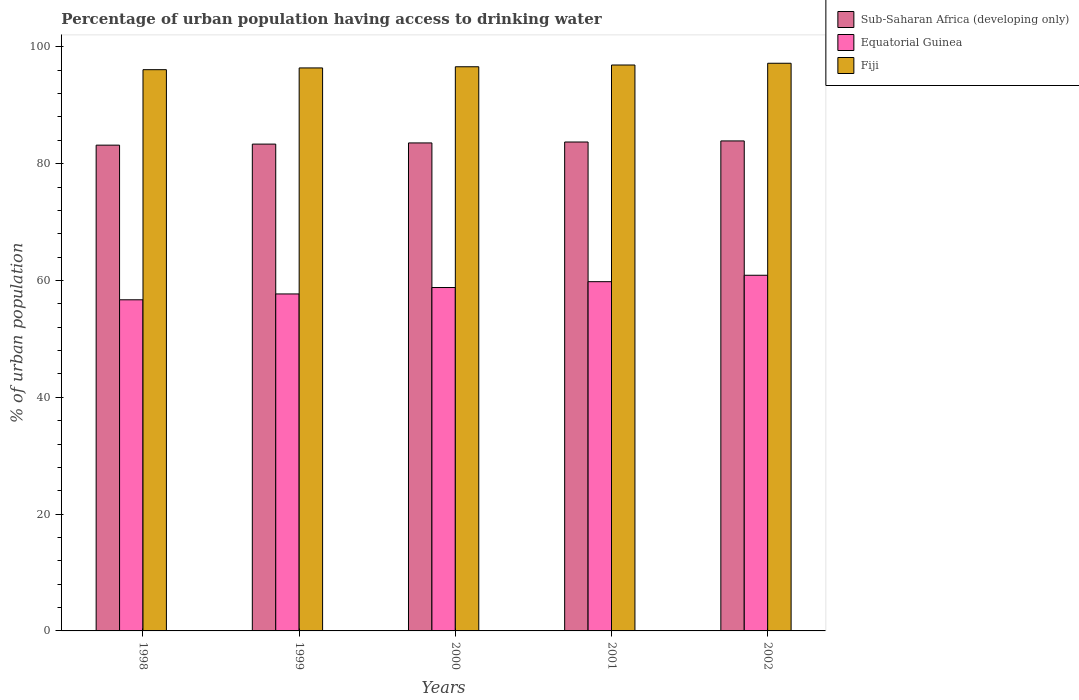How many different coloured bars are there?
Offer a very short reply. 3. How many groups of bars are there?
Provide a short and direct response. 5. Are the number of bars per tick equal to the number of legend labels?
Your response must be concise. Yes. In how many cases, is the number of bars for a given year not equal to the number of legend labels?
Offer a very short reply. 0. What is the percentage of urban population having access to drinking water in Equatorial Guinea in 2002?
Provide a succinct answer. 60.9. Across all years, what is the maximum percentage of urban population having access to drinking water in Sub-Saharan Africa (developing only)?
Your response must be concise. 83.9. Across all years, what is the minimum percentage of urban population having access to drinking water in Sub-Saharan Africa (developing only)?
Make the answer very short. 83.18. In which year was the percentage of urban population having access to drinking water in Equatorial Guinea maximum?
Make the answer very short. 2002. What is the total percentage of urban population having access to drinking water in Sub-Saharan Africa (developing only) in the graph?
Give a very brief answer. 417.71. What is the difference between the percentage of urban population having access to drinking water in Fiji in 2000 and that in 2001?
Ensure brevity in your answer.  -0.3. What is the difference between the percentage of urban population having access to drinking water in Fiji in 2001 and the percentage of urban population having access to drinking water in Sub-Saharan Africa (developing only) in 2002?
Provide a succinct answer. 13. What is the average percentage of urban population having access to drinking water in Sub-Saharan Africa (developing only) per year?
Give a very brief answer. 83.54. In the year 2001, what is the difference between the percentage of urban population having access to drinking water in Fiji and percentage of urban population having access to drinking water in Sub-Saharan Africa (developing only)?
Your answer should be compact. 13.18. What is the ratio of the percentage of urban population having access to drinking water in Sub-Saharan Africa (developing only) in 2000 to that in 2001?
Offer a very short reply. 1. What is the difference between the highest and the second highest percentage of urban population having access to drinking water in Sub-Saharan Africa (developing only)?
Give a very brief answer. 0.18. What is the difference between the highest and the lowest percentage of urban population having access to drinking water in Fiji?
Give a very brief answer. 1.1. In how many years, is the percentage of urban population having access to drinking water in Sub-Saharan Africa (developing only) greater than the average percentage of urban population having access to drinking water in Sub-Saharan Africa (developing only) taken over all years?
Your response must be concise. 3. What does the 1st bar from the left in 1999 represents?
Offer a very short reply. Sub-Saharan Africa (developing only). What does the 2nd bar from the right in 2001 represents?
Keep it short and to the point. Equatorial Guinea. Is it the case that in every year, the sum of the percentage of urban population having access to drinking water in Sub-Saharan Africa (developing only) and percentage of urban population having access to drinking water in Equatorial Guinea is greater than the percentage of urban population having access to drinking water in Fiji?
Give a very brief answer. Yes. How many bars are there?
Offer a terse response. 15. Are all the bars in the graph horizontal?
Keep it short and to the point. No. What is the difference between two consecutive major ticks on the Y-axis?
Your answer should be compact. 20. Are the values on the major ticks of Y-axis written in scientific E-notation?
Make the answer very short. No. Does the graph contain grids?
Offer a very short reply. No. What is the title of the graph?
Make the answer very short. Percentage of urban population having access to drinking water. Does "San Marino" appear as one of the legend labels in the graph?
Your response must be concise. No. What is the label or title of the X-axis?
Your answer should be very brief. Years. What is the label or title of the Y-axis?
Offer a terse response. % of urban population. What is the % of urban population of Sub-Saharan Africa (developing only) in 1998?
Offer a terse response. 83.18. What is the % of urban population of Equatorial Guinea in 1998?
Give a very brief answer. 56.7. What is the % of urban population in Fiji in 1998?
Your response must be concise. 96.1. What is the % of urban population in Sub-Saharan Africa (developing only) in 1999?
Ensure brevity in your answer.  83.36. What is the % of urban population in Equatorial Guinea in 1999?
Keep it short and to the point. 57.7. What is the % of urban population of Fiji in 1999?
Your response must be concise. 96.4. What is the % of urban population of Sub-Saharan Africa (developing only) in 2000?
Offer a very short reply. 83.56. What is the % of urban population in Equatorial Guinea in 2000?
Your response must be concise. 58.8. What is the % of urban population in Fiji in 2000?
Offer a terse response. 96.6. What is the % of urban population in Sub-Saharan Africa (developing only) in 2001?
Make the answer very short. 83.72. What is the % of urban population of Equatorial Guinea in 2001?
Your response must be concise. 59.8. What is the % of urban population in Fiji in 2001?
Your answer should be compact. 96.9. What is the % of urban population of Sub-Saharan Africa (developing only) in 2002?
Offer a very short reply. 83.9. What is the % of urban population in Equatorial Guinea in 2002?
Provide a succinct answer. 60.9. What is the % of urban population of Fiji in 2002?
Make the answer very short. 97.2. Across all years, what is the maximum % of urban population of Sub-Saharan Africa (developing only)?
Offer a terse response. 83.9. Across all years, what is the maximum % of urban population in Equatorial Guinea?
Keep it short and to the point. 60.9. Across all years, what is the maximum % of urban population of Fiji?
Provide a succinct answer. 97.2. Across all years, what is the minimum % of urban population of Sub-Saharan Africa (developing only)?
Your answer should be compact. 83.18. Across all years, what is the minimum % of urban population of Equatorial Guinea?
Keep it short and to the point. 56.7. Across all years, what is the minimum % of urban population in Fiji?
Provide a succinct answer. 96.1. What is the total % of urban population of Sub-Saharan Africa (developing only) in the graph?
Offer a very short reply. 417.71. What is the total % of urban population of Equatorial Guinea in the graph?
Provide a succinct answer. 293.9. What is the total % of urban population of Fiji in the graph?
Your answer should be very brief. 483.2. What is the difference between the % of urban population in Sub-Saharan Africa (developing only) in 1998 and that in 1999?
Provide a succinct answer. -0.18. What is the difference between the % of urban population of Fiji in 1998 and that in 1999?
Provide a succinct answer. -0.3. What is the difference between the % of urban population of Sub-Saharan Africa (developing only) in 1998 and that in 2000?
Offer a terse response. -0.38. What is the difference between the % of urban population of Equatorial Guinea in 1998 and that in 2000?
Keep it short and to the point. -2.1. What is the difference between the % of urban population in Fiji in 1998 and that in 2000?
Offer a very short reply. -0.5. What is the difference between the % of urban population of Sub-Saharan Africa (developing only) in 1998 and that in 2001?
Make the answer very short. -0.54. What is the difference between the % of urban population of Fiji in 1998 and that in 2001?
Offer a terse response. -0.8. What is the difference between the % of urban population in Sub-Saharan Africa (developing only) in 1998 and that in 2002?
Ensure brevity in your answer.  -0.72. What is the difference between the % of urban population of Equatorial Guinea in 1998 and that in 2002?
Provide a short and direct response. -4.2. What is the difference between the % of urban population of Fiji in 1998 and that in 2002?
Your response must be concise. -1.1. What is the difference between the % of urban population of Sub-Saharan Africa (developing only) in 1999 and that in 2000?
Ensure brevity in your answer.  -0.2. What is the difference between the % of urban population of Fiji in 1999 and that in 2000?
Offer a terse response. -0.2. What is the difference between the % of urban population of Sub-Saharan Africa (developing only) in 1999 and that in 2001?
Provide a succinct answer. -0.36. What is the difference between the % of urban population in Equatorial Guinea in 1999 and that in 2001?
Ensure brevity in your answer.  -2.1. What is the difference between the % of urban population of Fiji in 1999 and that in 2001?
Ensure brevity in your answer.  -0.5. What is the difference between the % of urban population in Sub-Saharan Africa (developing only) in 1999 and that in 2002?
Offer a terse response. -0.54. What is the difference between the % of urban population in Fiji in 1999 and that in 2002?
Provide a short and direct response. -0.8. What is the difference between the % of urban population in Sub-Saharan Africa (developing only) in 2000 and that in 2001?
Ensure brevity in your answer.  -0.16. What is the difference between the % of urban population of Equatorial Guinea in 2000 and that in 2001?
Keep it short and to the point. -1. What is the difference between the % of urban population of Sub-Saharan Africa (developing only) in 2000 and that in 2002?
Your response must be concise. -0.34. What is the difference between the % of urban population in Sub-Saharan Africa (developing only) in 2001 and that in 2002?
Offer a terse response. -0.18. What is the difference between the % of urban population of Equatorial Guinea in 2001 and that in 2002?
Offer a terse response. -1.1. What is the difference between the % of urban population of Sub-Saharan Africa (developing only) in 1998 and the % of urban population of Equatorial Guinea in 1999?
Offer a very short reply. 25.48. What is the difference between the % of urban population in Sub-Saharan Africa (developing only) in 1998 and the % of urban population in Fiji in 1999?
Provide a short and direct response. -13.22. What is the difference between the % of urban population in Equatorial Guinea in 1998 and the % of urban population in Fiji in 1999?
Your answer should be very brief. -39.7. What is the difference between the % of urban population in Sub-Saharan Africa (developing only) in 1998 and the % of urban population in Equatorial Guinea in 2000?
Your response must be concise. 24.38. What is the difference between the % of urban population in Sub-Saharan Africa (developing only) in 1998 and the % of urban population in Fiji in 2000?
Ensure brevity in your answer.  -13.42. What is the difference between the % of urban population of Equatorial Guinea in 1998 and the % of urban population of Fiji in 2000?
Make the answer very short. -39.9. What is the difference between the % of urban population of Sub-Saharan Africa (developing only) in 1998 and the % of urban population of Equatorial Guinea in 2001?
Provide a short and direct response. 23.38. What is the difference between the % of urban population of Sub-Saharan Africa (developing only) in 1998 and the % of urban population of Fiji in 2001?
Provide a succinct answer. -13.72. What is the difference between the % of urban population in Equatorial Guinea in 1998 and the % of urban population in Fiji in 2001?
Give a very brief answer. -40.2. What is the difference between the % of urban population in Sub-Saharan Africa (developing only) in 1998 and the % of urban population in Equatorial Guinea in 2002?
Give a very brief answer. 22.28. What is the difference between the % of urban population of Sub-Saharan Africa (developing only) in 1998 and the % of urban population of Fiji in 2002?
Your answer should be very brief. -14.02. What is the difference between the % of urban population of Equatorial Guinea in 1998 and the % of urban population of Fiji in 2002?
Provide a succinct answer. -40.5. What is the difference between the % of urban population of Sub-Saharan Africa (developing only) in 1999 and the % of urban population of Equatorial Guinea in 2000?
Your answer should be compact. 24.56. What is the difference between the % of urban population of Sub-Saharan Africa (developing only) in 1999 and the % of urban population of Fiji in 2000?
Offer a very short reply. -13.24. What is the difference between the % of urban population in Equatorial Guinea in 1999 and the % of urban population in Fiji in 2000?
Your answer should be very brief. -38.9. What is the difference between the % of urban population in Sub-Saharan Africa (developing only) in 1999 and the % of urban population in Equatorial Guinea in 2001?
Make the answer very short. 23.56. What is the difference between the % of urban population of Sub-Saharan Africa (developing only) in 1999 and the % of urban population of Fiji in 2001?
Your answer should be very brief. -13.54. What is the difference between the % of urban population in Equatorial Guinea in 1999 and the % of urban population in Fiji in 2001?
Give a very brief answer. -39.2. What is the difference between the % of urban population in Sub-Saharan Africa (developing only) in 1999 and the % of urban population in Equatorial Guinea in 2002?
Your answer should be very brief. 22.46. What is the difference between the % of urban population in Sub-Saharan Africa (developing only) in 1999 and the % of urban population in Fiji in 2002?
Offer a very short reply. -13.84. What is the difference between the % of urban population in Equatorial Guinea in 1999 and the % of urban population in Fiji in 2002?
Offer a terse response. -39.5. What is the difference between the % of urban population in Sub-Saharan Africa (developing only) in 2000 and the % of urban population in Equatorial Guinea in 2001?
Your answer should be very brief. 23.76. What is the difference between the % of urban population of Sub-Saharan Africa (developing only) in 2000 and the % of urban population of Fiji in 2001?
Offer a terse response. -13.34. What is the difference between the % of urban population of Equatorial Guinea in 2000 and the % of urban population of Fiji in 2001?
Your answer should be compact. -38.1. What is the difference between the % of urban population of Sub-Saharan Africa (developing only) in 2000 and the % of urban population of Equatorial Guinea in 2002?
Keep it short and to the point. 22.66. What is the difference between the % of urban population of Sub-Saharan Africa (developing only) in 2000 and the % of urban population of Fiji in 2002?
Give a very brief answer. -13.64. What is the difference between the % of urban population of Equatorial Guinea in 2000 and the % of urban population of Fiji in 2002?
Offer a terse response. -38.4. What is the difference between the % of urban population in Sub-Saharan Africa (developing only) in 2001 and the % of urban population in Equatorial Guinea in 2002?
Provide a short and direct response. 22.82. What is the difference between the % of urban population of Sub-Saharan Africa (developing only) in 2001 and the % of urban population of Fiji in 2002?
Offer a very short reply. -13.48. What is the difference between the % of urban population of Equatorial Guinea in 2001 and the % of urban population of Fiji in 2002?
Your response must be concise. -37.4. What is the average % of urban population of Sub-Saharan Africa (developing only) per year?
Your response must be concise. 83.54. What is the average % of urban population of Equatorial Guinea per year?
Your response must be concise. 58.78. What is the average % of urban population in Fiji per year?
Provide a succinct answer. 96.64. In the year 1998, what is the difference between the % of urban population of Sub-Saharan Africa (developing only) and % of urban population of Equatorial Guinea?
Provide a succinct answer. 26.48. In the year 1998, what is the difference between the % of urban population in Sub-Saharan Africa (developing only) and % of urban population in Fiji?
Ensure brevity in your answer.  -12.92. In the year 1998, what is the difference between the % of urban population of Equatorial Guinea and % of urban population of Fiji?
Ensure brevity in your answer.  -39.4. In the year 1999, what is the difference between the % of urban population of Sub-Saharan Africa (developing only) and % of urban population of Equatorial Guinea?
Offer a terse response. 25.66. In the year 1999, what is the difference between the % of urban population in Sub-Saharan Africa (developing only) and % of urban population in Fiji?
Offer a terse response. -13.04. In the year 1999, what is the difference between the % of urban population in Equatorial Guinea and % of urban population in Fiji?
Provide a short and direct response. -38.7. In the year 2000, what is the difference between the % of urban population in Sub-Saharan Africa (developing only) and % of urban population in Equatorial Guinea?
Provide a succinct answer. 24.76. In the year 2000, what is the difference between the % of urban population of Sub-Saharan Africa (developing only) and % of urban population of Fiji?
Your answer should be very brief. -13.04. In the year 2000, what is the difference between the % of urban population in Equatorial Guinea and % of urban population in Fiji?
Your response must be concise. -37.8. In the year 2001, what is the difference between the % of urban population in Sub-Saharan Africa (developing only) and % of urban population in Equatorial Guinea?
Offer a terse response. 23.92. In the year 2001, what is the difference between the % of urban population of Sub-Saharan Africa (developing only) and % of urban population of Fiji?
Your answer should be very brief. -13.18. In the year 2001, what is the difference between the % of urban population in Equatorial Guinea and % of urban population in Fiji?
Make the answer very short. -37.1. In the year 2002, what is the difference between the % of urban population in Sub-Saharan Africa (developing only) and % of urban population in Equatorial Guinea?
Give a very brief answer. 23. In the year 2002, what is the difference between the % of urban population of Sub-Saharan Africa (developing only) and % of urban population of Fiji?
Offer a terse response. -13.3. In the year 2002, what is the difference between the % of urban population of Equatorial Guinea and % of urban population of Fiji?
Provide a short and direct response. -36.3. What is the ratio of the % of urban population in Equatorial Guinea in 1998 to that in 1999?
Make the answer very short. 0.98. What is the ratio of the % of urban population of Fiji in 1998 to that in 2000?
Your answer should be compact. 0.99. What is the ratio of the % of urban population of Sub-Saharan Africa (developing only) in 1998 to that in 2001?
Your answer should be compact. 0.99. What is the ratio of the % of urban population in Equatorial Guinea in 1998 to that in 2001?
Provide a short and direct response. 0.95. What is the ratio of the % of urban population in Fiji in 1998 to that in 2001?
Your response must be concise. 0.99. What is the ratio of the % of urban population of Fiji in 1998 to that in 2002?
Offer a terse response. 0.99. What is the ratio of the % of urban population in Sub-Saharan Africa (developing only) in 1999 to that in 2000?
Offer a terse response. 1. What is the ratio of the % of urban population of Equatorial Guinea in 1999 to that in 2000?
Provide a short and direct response. 0.98. What is the ratio of the % of urban population of Equatorial Guinea in 1999 to that in 2001?
Offer a terse response. 0.96. What is the ratio of the % of urban population of Sub-Saharan Africa (developing only) in 1999 to that in 2002?
Keep it short and to the point. 0.99. What is the ratio of the % of urban population in Equatorial Guinea in 1999 to that in 2002?
Ensure brevity in your answer.  0.95. What is the ratio of the % of urban population in Equatorial Guinea in 2000 to that in 2001?
Your response must be concise. 0.98. What is the ratio of the % of urban population in Equatorial Guinea in 2000 to that in 2002?
Make the answer very short. 0.97. What is the ratio of the % of urban population of Fiji in 2000 to that in 2002?
Your answer should be compact. 0.99. What is the ratio of the % of urban population of Equatorial Guinea in 2001 to that in 2002?
Offer a terse response. 0.98. What is the ratio of the % of urban population in Fiji in 2001 to that in 2002?
Your response must be concise. 1. What is the difference between the highest and the second highest % of urban population of Sub-Saharan Africa (developing only)?
Offer a terse response. 0.18. What is the difference between the highest and the second highest % of urban population of Equatorial Guinea?
Provide a short and direct response. 1.1. What is the difference between the highest and the second highest % of urban population in Fiji?
Offer a terse response. 0.3. What is the difference between the highest and the lowest % of urban population of Sub-Saharan Africa (developing only)?
Give a very brief answer. 0.72. What is the difference between the highest and the lowest % of urban population in Equatorial Guinea?
Keep it short and to the point. 4.2. 